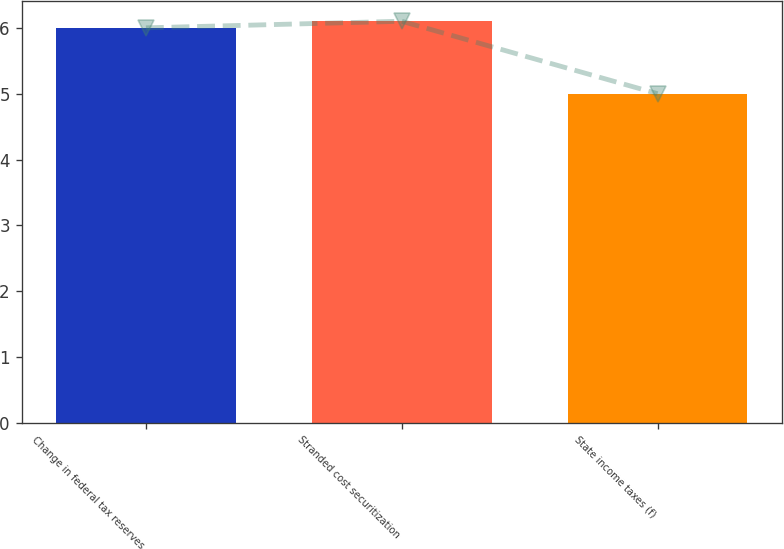Convert chart to OTSL. <chart><loc_0><loc_0><loc_500><loc_500><bar_chart><fcel>Change in federal tax reserves<fcel>Stranded cost securitization<fcel>State income taxes (f)<nl><fcel>6<fcel>6.1<fcel>5<nl></chart> 